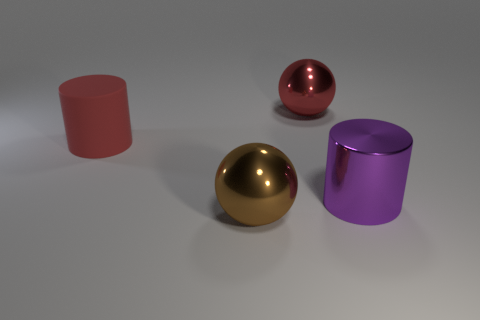Add 3 purple objects. How many objects exist? 7 Subtract 2 cylinders. How many cylinders are left? 0 Subtract all large matte cylinders. Subtract all large red cylinders. How many objects are left? 2 Add 2 big objects. How many big objects are left? 6 Add 2 red matte objects. How many red matte objects exist? 3 Subtract 1 brown balls. How many objects are left? 3 Subtract all blue balls. Subtract all red blocks. How many balls are left? 2 